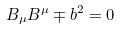<formula> <loc_0><loc_0><loc_500><loc_500>B _ { \mu } B ^ { \mu } \mp b ^ { 2 } = 0</formula> 